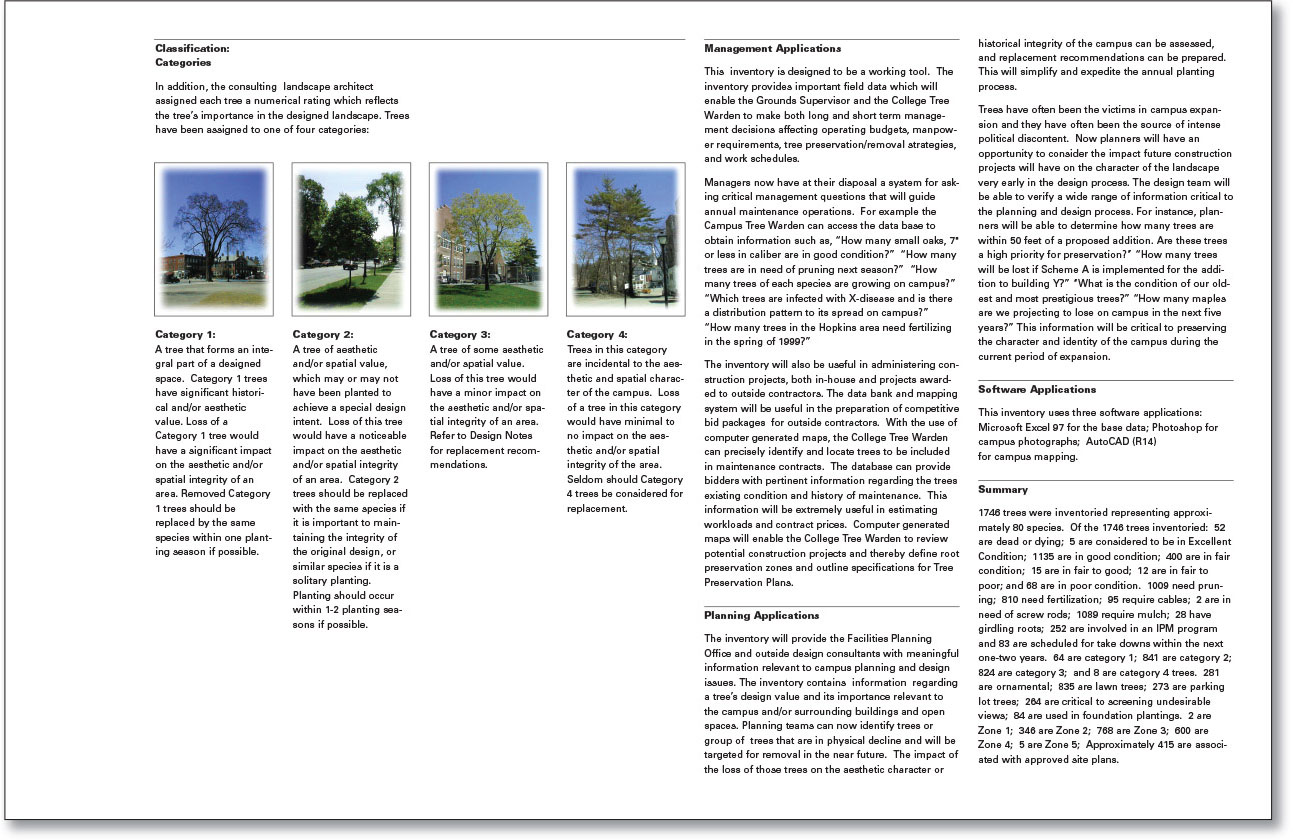Considering climate change, how might the campus tree management strategy evolve? As climate change intensifies, the campus tree management strategy might evolve to place greater emphasis on selecting tree species resilient to changing weather patterns and more extreme conditions. This could involve choosing species that are drought-tolerant or can withstand severe storms. There might also be an increased focus on biodiversity to ensure the campus landscape can adapt to various environmental stressors. Furthermore, the strategy might incorporate more advanced monitoring and data analysis technologies to track tree health and anticipate climate-related challenges, ensuring proactive rather than reactive management. 